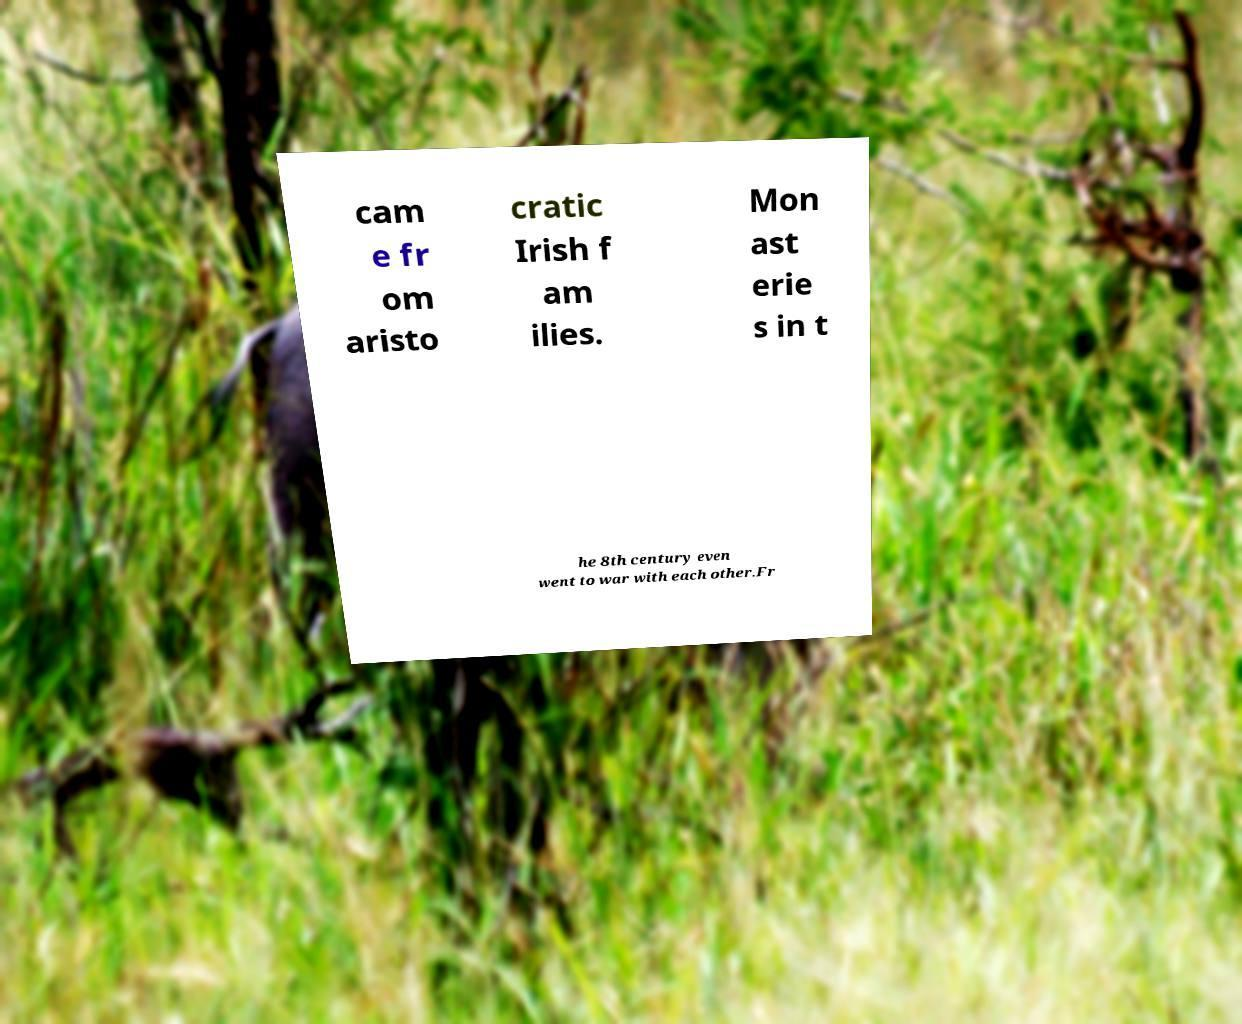Could you extract and type out the text from this image? cam e fr om aristo cratic Irish f am ilies. Mon ast erie s in t he 8th century even went to war with each other.Fr 